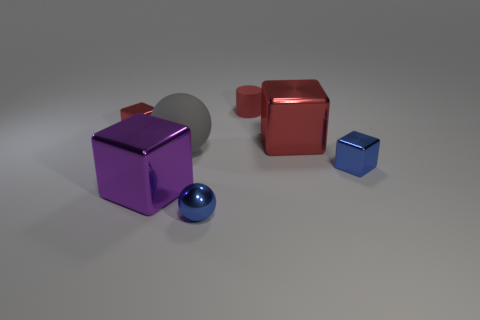Analyze the colors and materials of the objects. In the image, we see objects with different colors and materials. The blue and red cubes have a reflective, metallic finish that gives them a shiny appearance, catching the light and reflecting their surroundings. The purple cube has a slightly less glossy finish but is still reflective, indicating a metallic texture. The gray sphere has a matte surface, absorbing more light and thus reflecting less. 